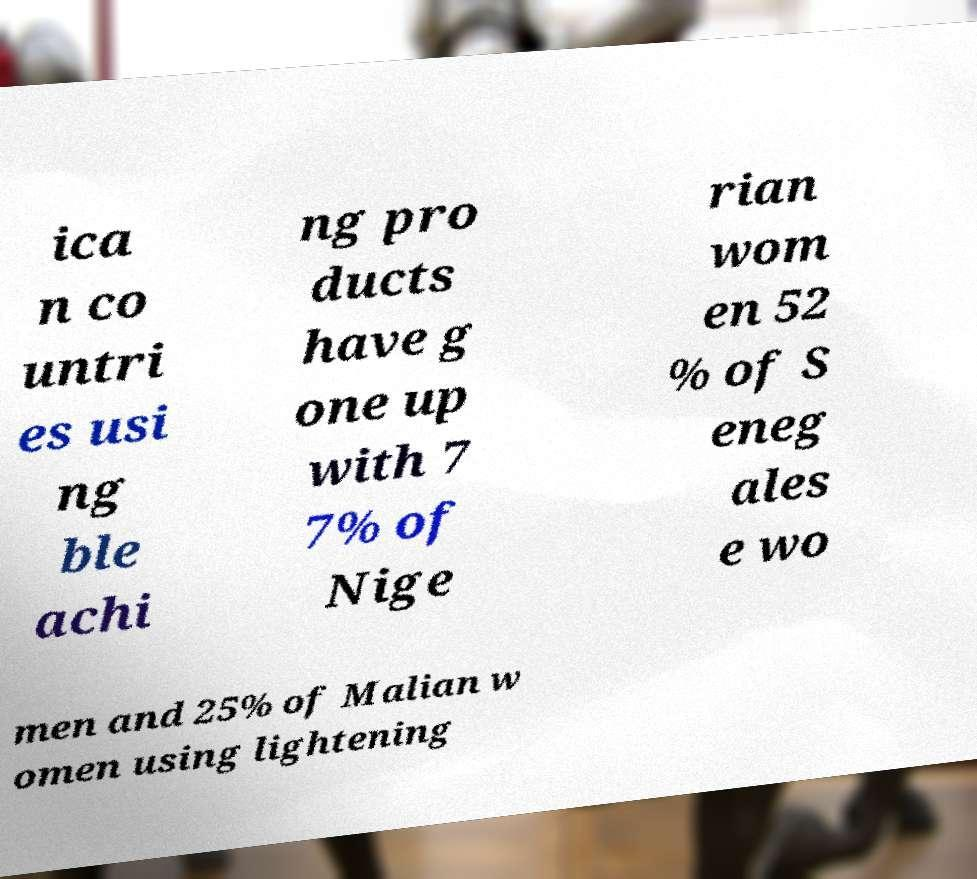I need the written content from this picture converted into text. Can you do that? ica n co untri es usi ng ble achi ng pro ducts have g one up with 7 7% of Nige rian wom en 52 % of S eneg ales e wo men and 25% of Malian w omen using lightening 